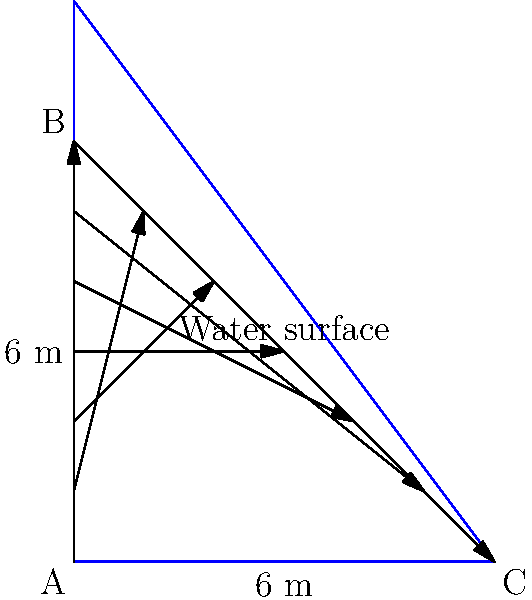Robert, as a civil engineer, you're tasked with analyzing the water pressure distribution on a triangular dam wall. The dam has a height of 6 meters and a base width of 6 meters. The water level reaches the top of the dam. Calculate the total hydrostatic force $F$ (in kN) acting on the dam wall per meter length of the dam.

Given:
- Density of water, $\rho = 1000 \text{ kg/m}^3$
- Gravitational acceleration, $g = 9.81 \text{ m/s}^2$ Let's approach this step-by-step:

1) The pressure at any depth $h$ in a fluid is given by $p = \rho gh$, where $\rho$ is the density of the fluid and $g$ is the gravitational acceleration.

2) The pressure distribution on the dam wall is triangular, with zero pressure at the water surface and maximum pressure at the bottom.

3) The maximum pressure at the bottom (6 m depth) is:
   $p_{max} = \rho gh = 1000 \times 9.81 \times 6 = 58860 \text{ Pa} = 58.86 \text{ kPa}$

4) The average pressure over the dam wall is half of the maximum pressure:
   $p_{avg} = \frac{1}{2} p_{max} = \frac{1}{2} \times 58.86 = 29.43 \text{ kPa}$

5) The area of the dam wall (per meter length) is:
   $A = \frac{1}{2} \times \text{base} \times \text{height} = \frac{1}{2} \times 6 \times 6 = 18 \text{ m}^2$

6) The total hydrostatic force is the product of the average pressure and the area:
   $F = p_{avg} \times A = 29.43 \times 18 = 529.74 \text{ kN}$

Therefore, the total hydrostatic force acting on the dam wall per meter length is approximately 529.74 kN.
Answer: 529.74 kN 